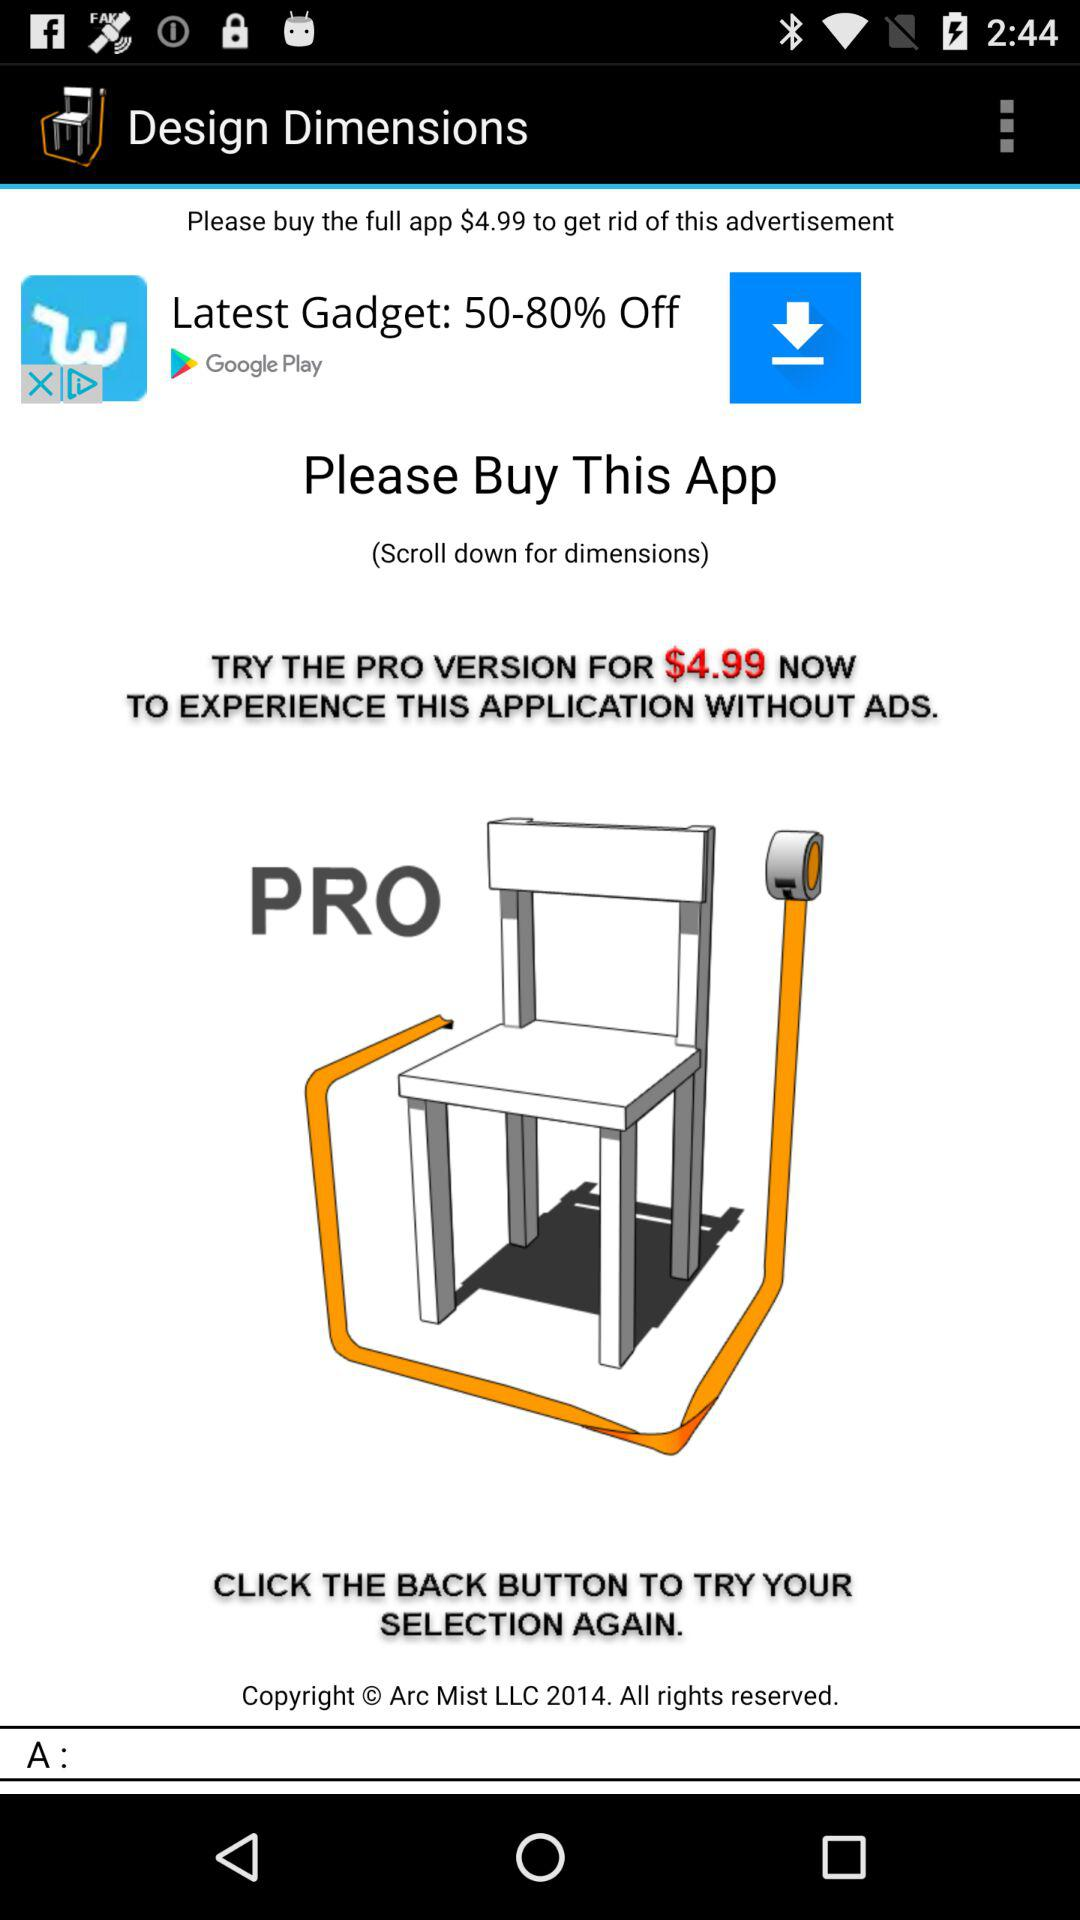What is the price for upgrading to the pro version? The price is $4.99. 